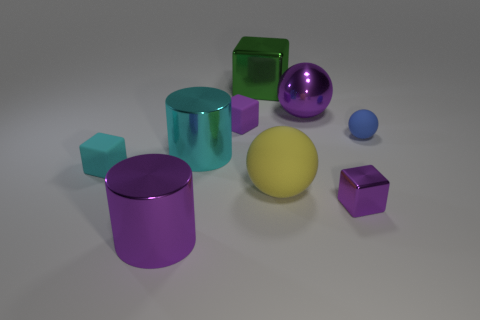The cyan cylinder that is made of the same material as the big cube is what size?
Your answer should be very brief. Large. There is a cylinder that is the same color as the small metal object; what is its size?
Provide a succinct answer. Large. What is the size of the shiny object that is the same shape as the yellow rubber thing?
Your answer should be very brief. Large. How many small purple objects have the same material as the green block?
Offer a terse response. 1. There is a rubber block in front of the matte cube to the right of the cyan metallic cylinder; what size is it?
Ensure brevity in your answer.  Small. Is there a large purple shiny object that has the same shape as the small blue matte thing?
Your response must be concise. Yes. There is a matte object that is on the right side of the purple metal sphere; is its size the same as the rubber block that is on the left side of the purple matte thing?
Keep it short and to the point. Yes. Are there fewer large purple shiny things that are in front of the tiny purple matte thing than big purple metal objects that are in front of the tiny blue rubber ball?
Give a very brief answer. No. There is a cylinder that is the same color as the large metallic sphere; what is it made of?
Offer a very short reply. Metal. What is the color of the rubber thing behind the blue matte sphere?
Offer a very short reply. Purple. 